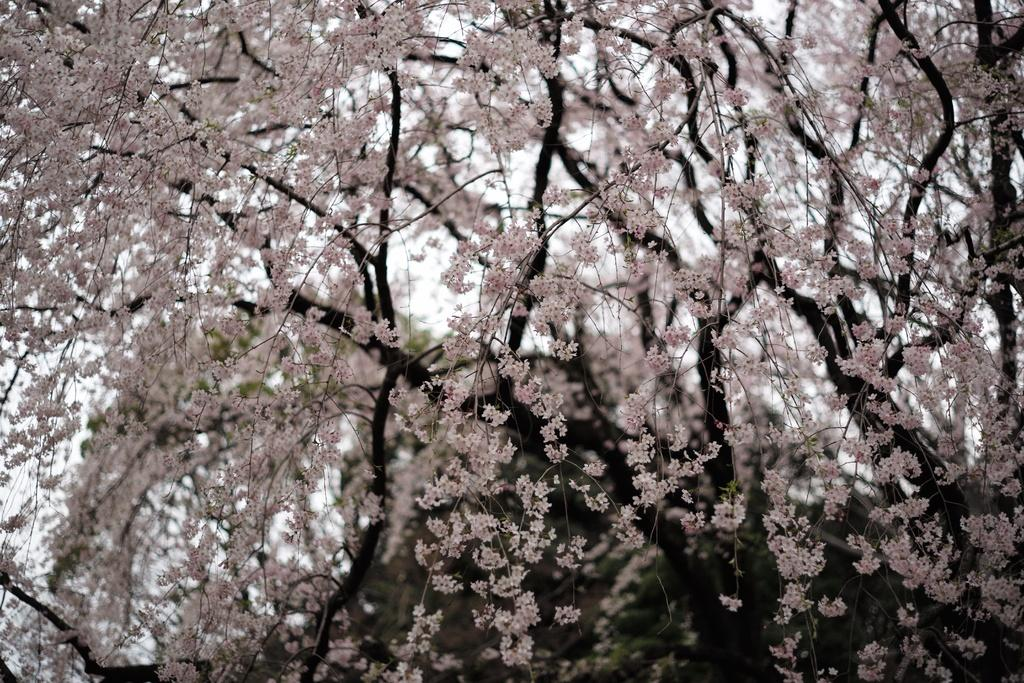What is the primary feature of the image? There are many trees in the image. What can be seen in the distance behind the trees? The sky is visible in the background of the image. Can you describe the trees in the image? The facts provided do not give specific details about the trees, but we can say that there are multiple trees present. What type of flower is being held by the hand in the image? There is no hand or flower present in the image; it only features trees and the sky. 